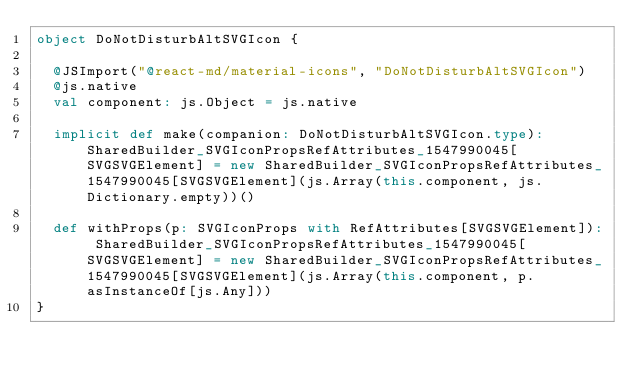Convert code to text. <code><loc_0><loc_0><loc_500><loc_500><_Scala_>object DoNotDisturbAltSVGIcon {
  
  @JSImport("@react-md/material-icons", "DoNotDisturbAltSVGIcon")
  @js.native
  val component: js.Object = js.native
  
  implicit def make(companion: DoNotDisturbAltSVGIcon.type): SharedBuilder_SVGIconPropsRefAttributes_1547990045[SVGSVGElement] = new SharedBuilder_SVGIconPropsRefAttributes_1547990045[SVGSVGElement](js.Array(this.component, js.Dictionary.empty))()
  
  def withProps(p: SVGIconProps with RefAttributes[SVGSVGElement]): SharedBuilder_SVGIconPropsRefAttributes_1547990045[SVGSVGElement] = new SharedBuilder_SVGIconPropsRefAttributes_1547990045[SVGSVGElement](js.Array(this.component, p.asInstanceOf[js.Any]))
}
</code> 